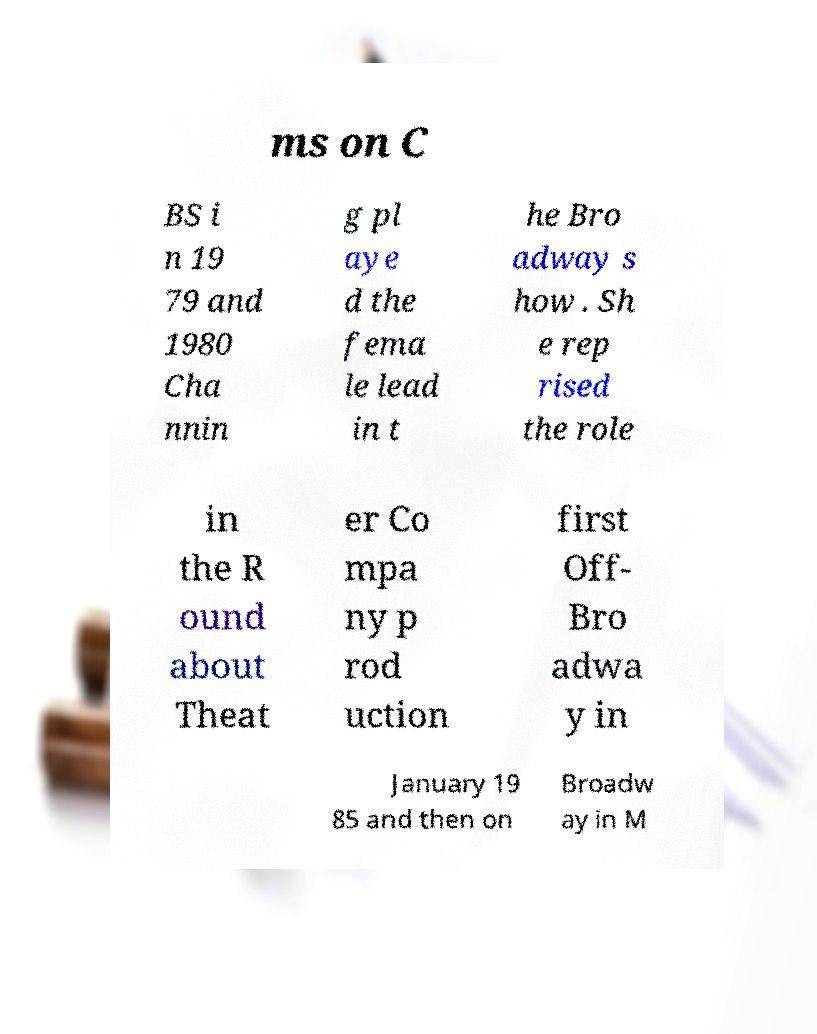Could you extract and type out the text from this image? ms on C BS i n 19 79 and 1980 Cha nnin g pl aye d the fema le lead in t he Bro adway s how . Sh e rep rised the role in the R ound about Theat er Co mpa ny p rod uction first Off- Bro adwa y in January 19 85 and then on Broadw ay in M 